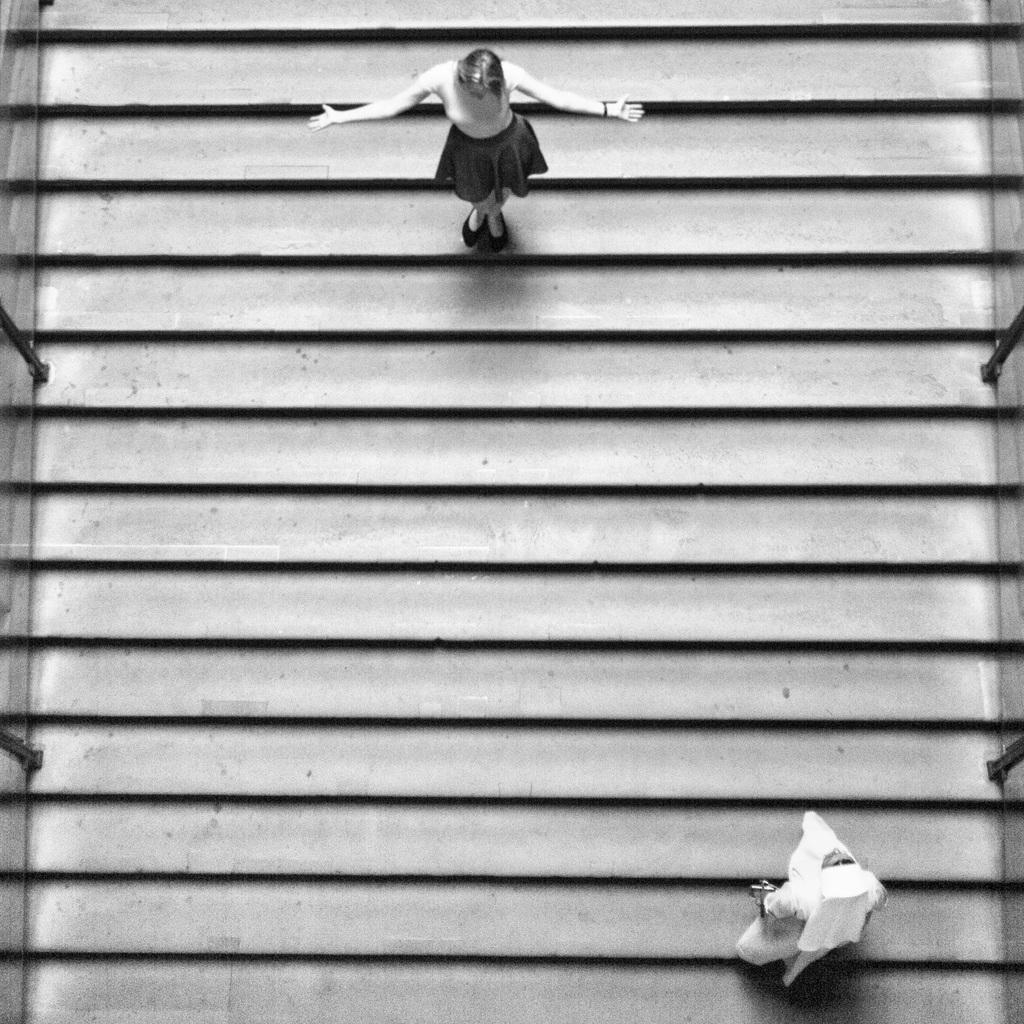What can be seen in the image that allows for movement between different levels? There are stairs in the image. How many people are present in the image? There are two persons in the image. Can you describe one of the persons in the image? One of the persons is a woman. Where is the woman located in the image? The woman is on the right side of the image. What is the woman's position in relation to the stairs? The woman is at the bottom of the stairs. What is the woman wearing in the image? The woman is wearing a white color dress. What holiday is being celebrated in the image? There is no indication of a holiday being celebrated in the image. Is the woman in the image the viewer's aunt? There is no information provided about the relationship between the woman and the viewer, so it cannot be determined if she is the viewer's aunt. 